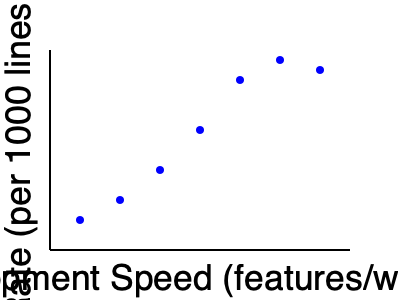Based on the scatter plot showing the relationship between development speed and defect rate, what conclusion can be drawn about the impact of rushing the development process on product quality? To analyze the scatter plot and draw a conclusion about the impact of rushing the development process on product quality, we need to follow these steps:

1. Identify the variables:
   - X-axis: Development Speed (features/week)
   - Y-axis: Defect Rate (per 1000 lines of code)

2. Observe the general trend:
   As we move from left to right (increasing development speed), the data points tend to move upwards (increasing defect rate).

3. Analyze the correlation:
   There appears to be a positive correlation between development speed and defect rate. This means that as development speed increases, the defect rate tends to increase as well.

4. Consider the strength of the relationship:
   The data points follow a relatively clear pattern, suggesting a strong positive correlation.

5. Interpret the results in the context of the question:
   Rushing the development process (increasing development speed) is associated with higher defect rates, which indicates lower product quality.

6. Draw a conclusion:
   Based on the scatter plot, we can conclude that rushing the development process has a negative impact on product quality, as evidenced by the increase in defect rates when development speed increases.
Answer: Rushing development negatively impacts product quality, increasing defect rates. 